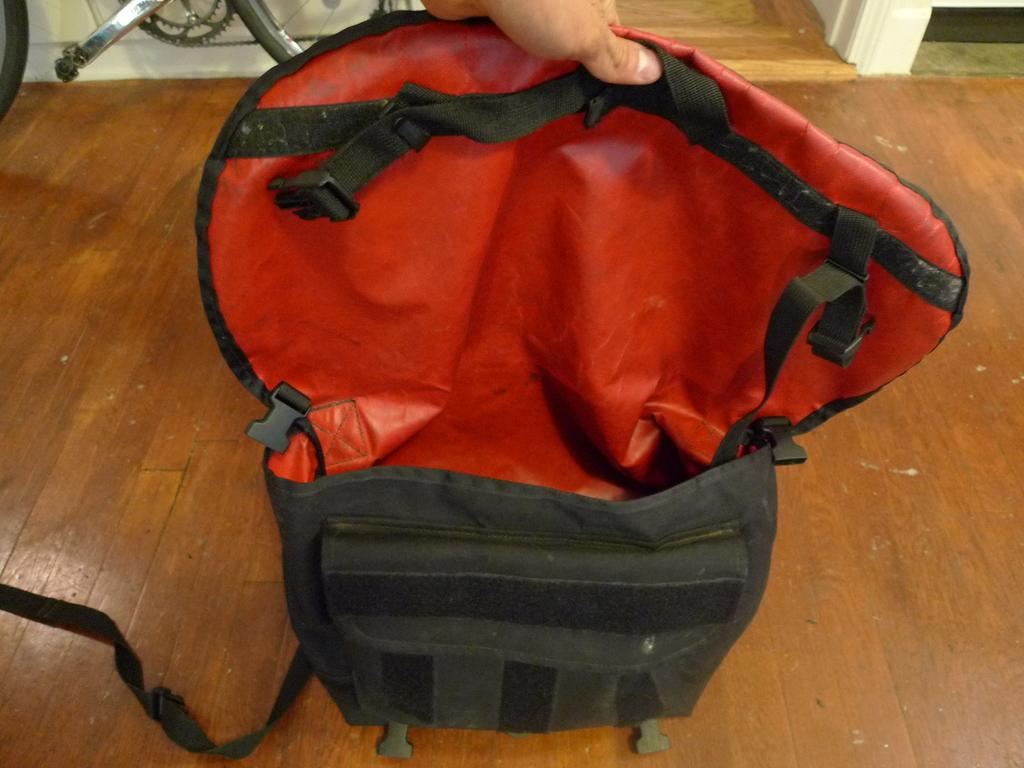What is the color of the bag in the image? The bag in the image is black. What color is the inside of the bag? The inside of the bag is red in color. Can you see any part of a person in the image? Yes, there is a hand of a person visible in the image. What else can be seen in the image besides the bag and the hand? There is a bicycle in the image. How does the person in the image maintain their balance while crossing the stream? There is no stream present in the image, and the person's balance is not relevant to the image's content. 